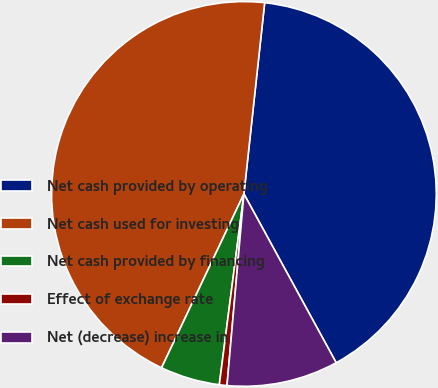Convert chart. <chart><loc_0><loc_0><loc_500><loc_500><pie_chart><fcel>Net cash provided by operating<fcel>Net cash used for investing<fcel>Net cash provided by financing<fcel>Effect of exchange rate<fcel>Net (decrease) increase in<nl><fcel>40.31%<fcel>44.67%<fcel>5.0%<fcel>0.64%<fcel>9.36%<nl></chart> 